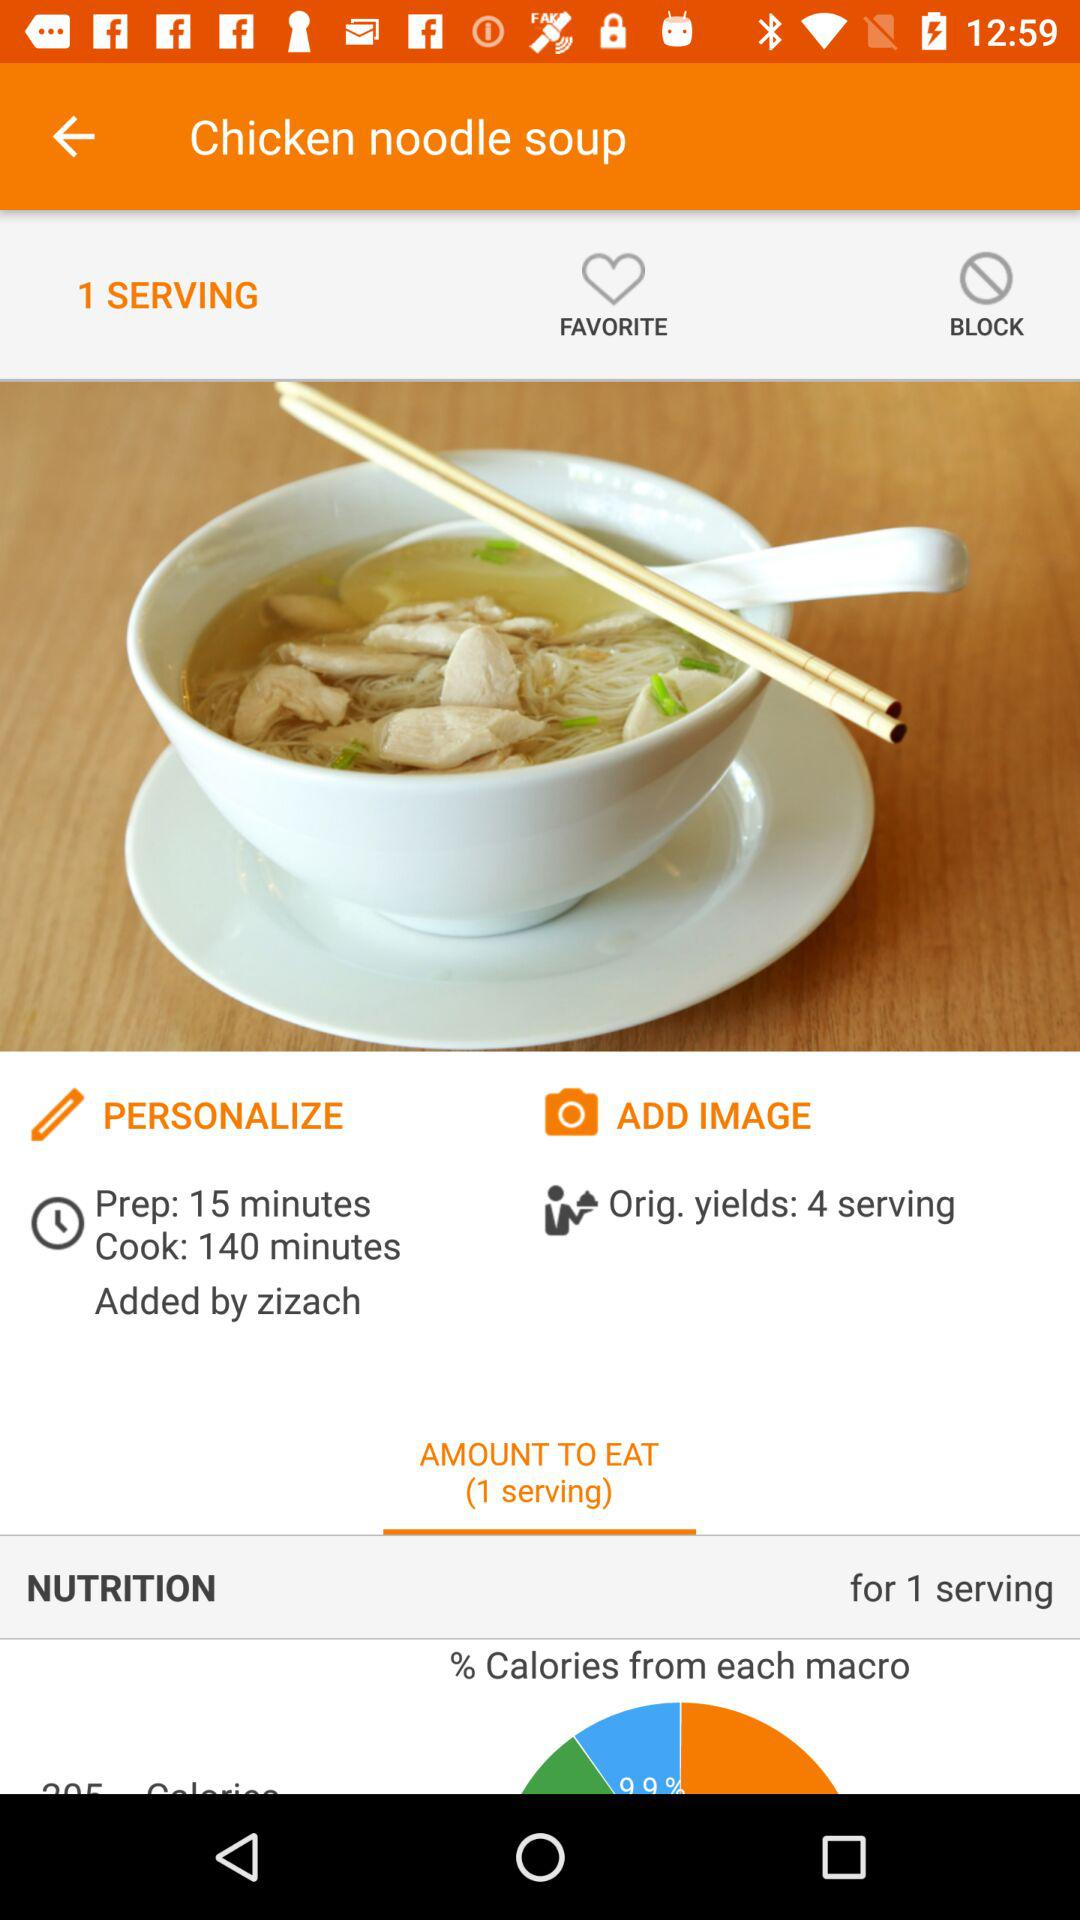How many servings does the recipe yield?
Answer the question using a single word or phrase. 4 